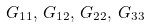<formula> <loc_0><loc_0><loc_500><loc_500>G _ { 1 1 } , \, G _ { 1 2 } , \, G _ { 2 2 } , \, G _ { 3 3 }</formula> 